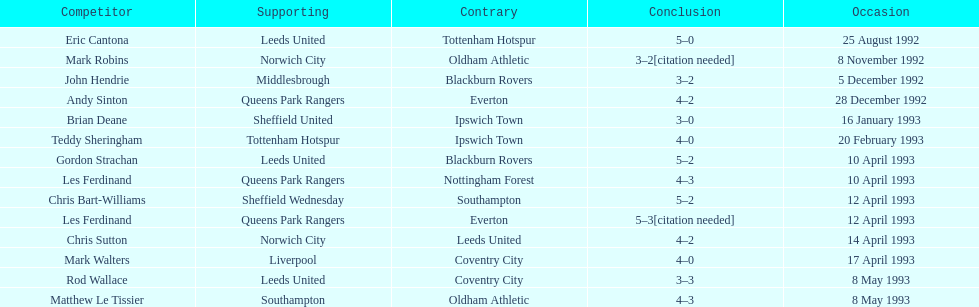Could you help me parse every detail presented in this table? {'header': ['Competitor', 'Supporting', 'Contrary', 'Conclusion', 'Occasion'], 'rows': [['Eric Cantona', 'Leeds United', 'Tottenham Hotspur', '5–0', '25 August 1992'], ['Mark Robins', 'Norwich City', 'Oldham Athletic', '3–2[citation needed]', '8 November 1992'], ['John Hendrie', 'Middlesbrough', 'Blackburn Rovers', '3–2', '5 December 1992'], ['Andy Sinton', 'Queens Park Rangers', 'Everton', '4–2', '28 December 1992'], ['Brian Deane', 'Sheffield United', 'Ipswich Town', '3–0', '16 January 1993'], ['Teddy Sheringham', 'Tottenham Hotspur', 'Ipswich Town', '4–0', '20 February 1993'], ['Gordon Strachan', 'Leeds United', 'Blackburn Rovers', '5–2', '10 April 1993'], ['Les Ferdinand', 'Queens Park Rangers', 'Nottingham Forest', '4–3', '10 April 1993'], ['Chris Bart-Williams', 'Sheffield Wednesday', 'Southampton', '5–2', '12 April 1993'], ['Les Ferdinand', 'Queens Park Rangers', 'Everton', '5–3[citation needed]', '12 April 1993'], ['Chris Sutton', 'Norwich City', 'Leeds United', '4–2', '14 April 1993'], ['Mark Walters', 'Liverpool', 'Coventry City', '4–0', '17 April 1993'], ['Rod Wallace', 'Leeds United', 'Coventry City', '3–3', '8 May 1993'], ['Matthew Le Tissier', 'Southampton', 'Oldham Athletic', '4–3', '8 May 1993']]} Southampton played on may 8th, 1993, who was their opponent? Oldham Athletic. 